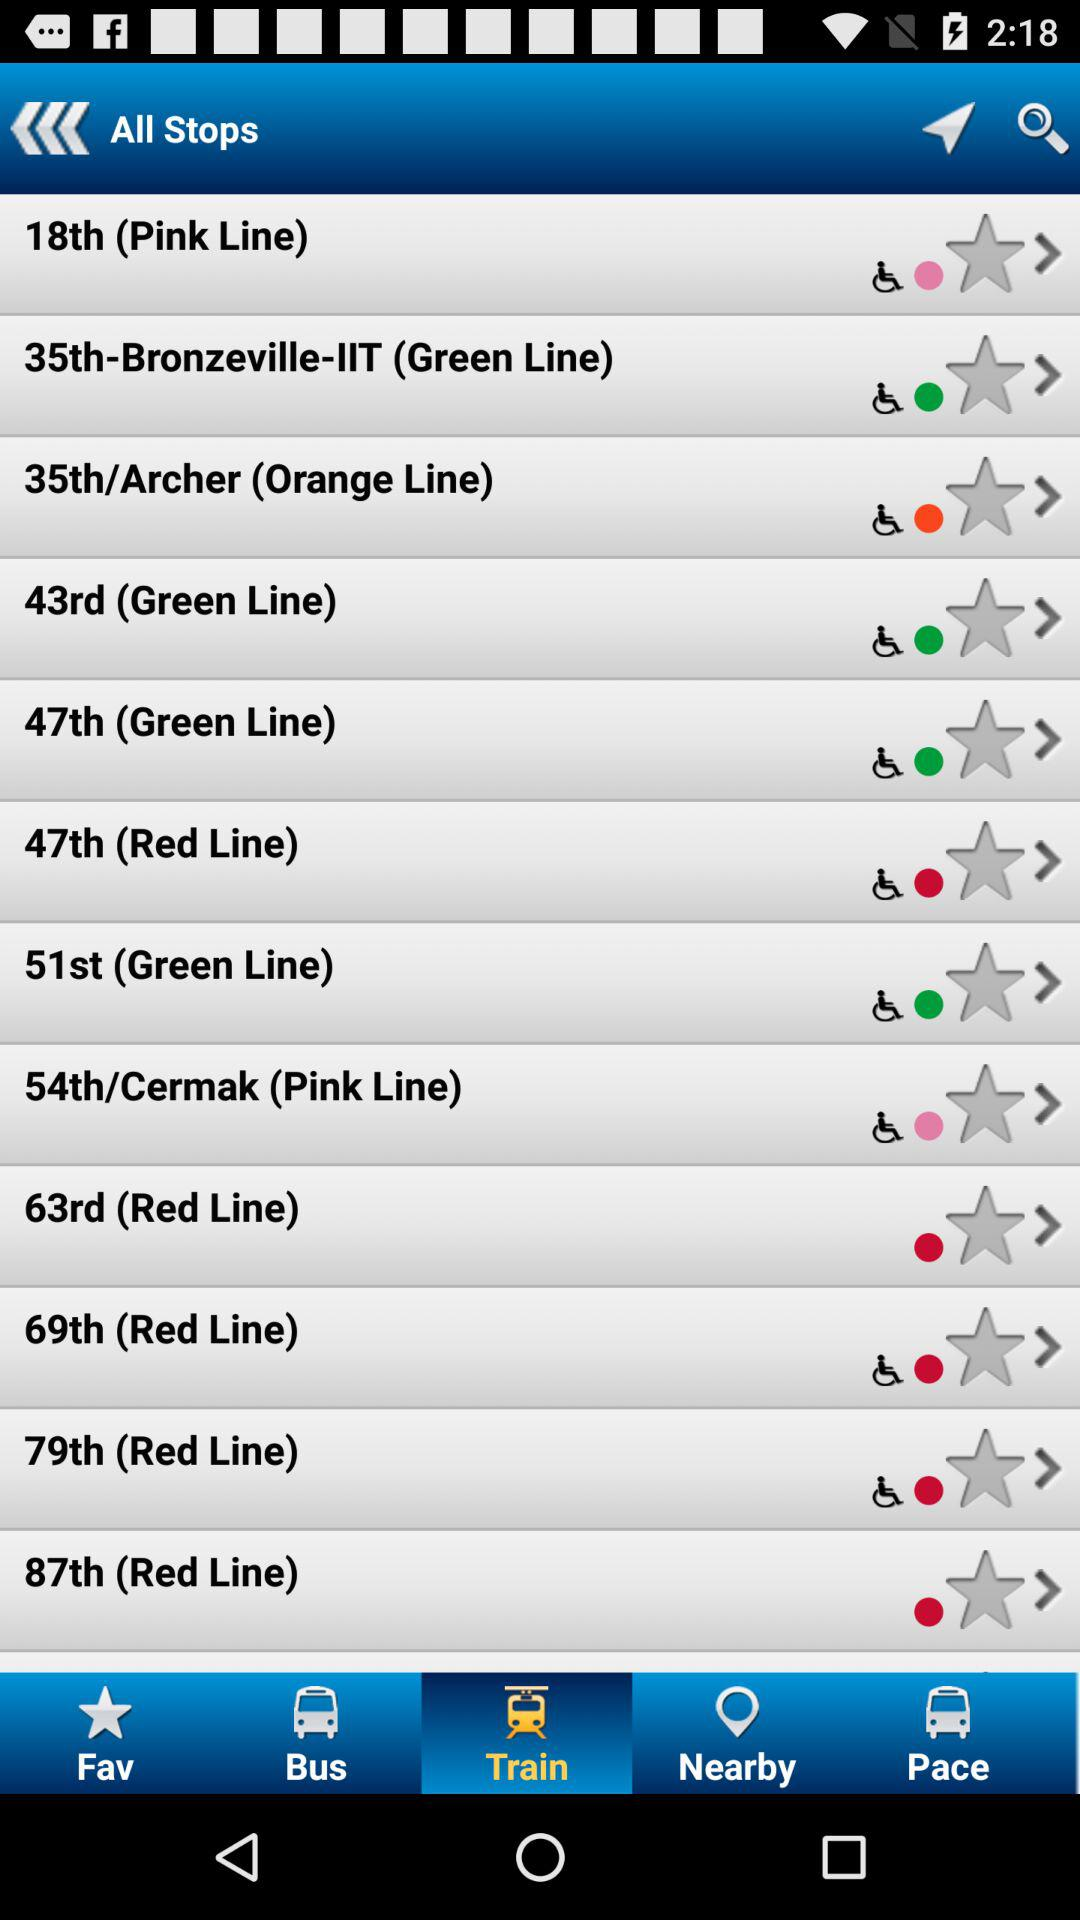Which color line does the "54th/Cermak" stop fall on? The "54th/Cermak" stop falls on the pink line. 